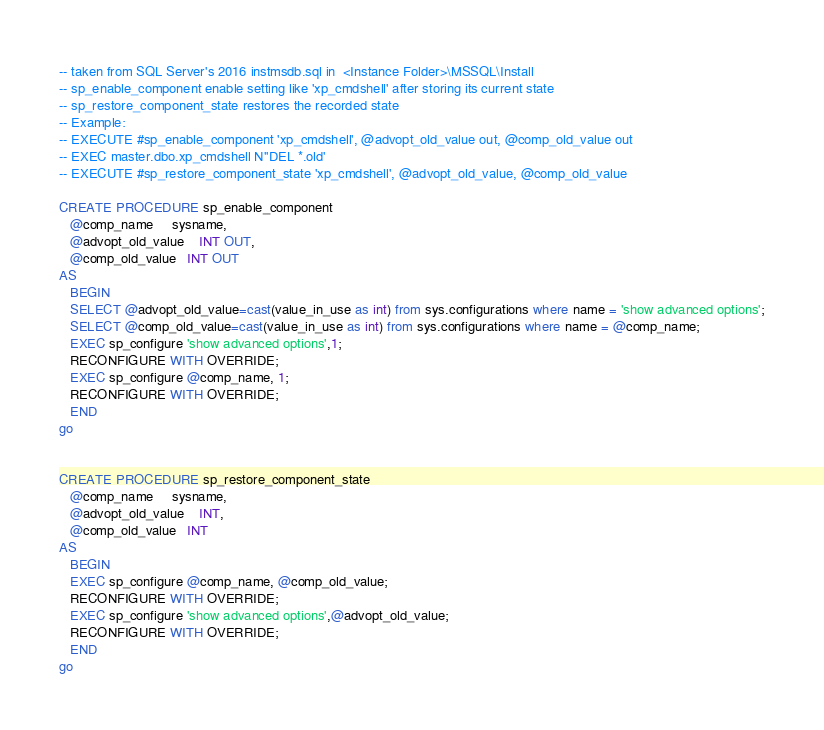<code> <loc_0><loc_0><loc_500><loc_500><_SQL_>-- taken from SQL Server's 2016 instmsdb.sql in  <Instance Folder>\MSSQL\Install
-- sp_enable_component enable setting like 'xp_cmdshell' after storing its current state
-- sp_restore_component_state restores the recorded state
-- Example:
-- EXECUTE #sp_enable_component 'xp_cmdshell', @advopt_old_value out, @comp_old_value out
-- EXEC master.dbo.xp_cmdshell N''DEL *.old'
-- EXECUTE #sp_restore_component_state 'xp_cmdshell', @advopt_old_value, @comp_old_value
	
CREATE PROCEDURE sp_enable_component     
   @comp_name     sysname, 
   @advopt_old_value    INT OUT, 
   @comp_old_value   INT OUT 
AS
   BEGIN
   SELECT @advopt_old_value=cast(value_in_use as int) from sys.configurations where name = 'show advanced options';
   SELECT @comp_old_value=cast(value_in_use as int) from sys.configurations where name = @comp_name; 
   EXEC sp_configure 'show advanced options',1;
   RECONFIGURE WITH OVERRIDE;
   EXEC sp_configure @comp_name, 1; 
   RECONFIGURE WITH OVERRIDE;
   END
go


CREATE PROCEDURE sp_restore_component_state 
   @comp_name     sysname, 
   @advopt_old_value    INT, 
   @comp_old_value   INT 
AS
   BEGIN
   EXEC sp_configure @comp_name, @comp_old_value; 
   RECONFIGURE WITH OVERRIDE;
   EXEC sp_configure 'show advanced options',@advopt_old_value;
   RECONFIGURE WITH OVERRIDE;
   END
go
</code> 